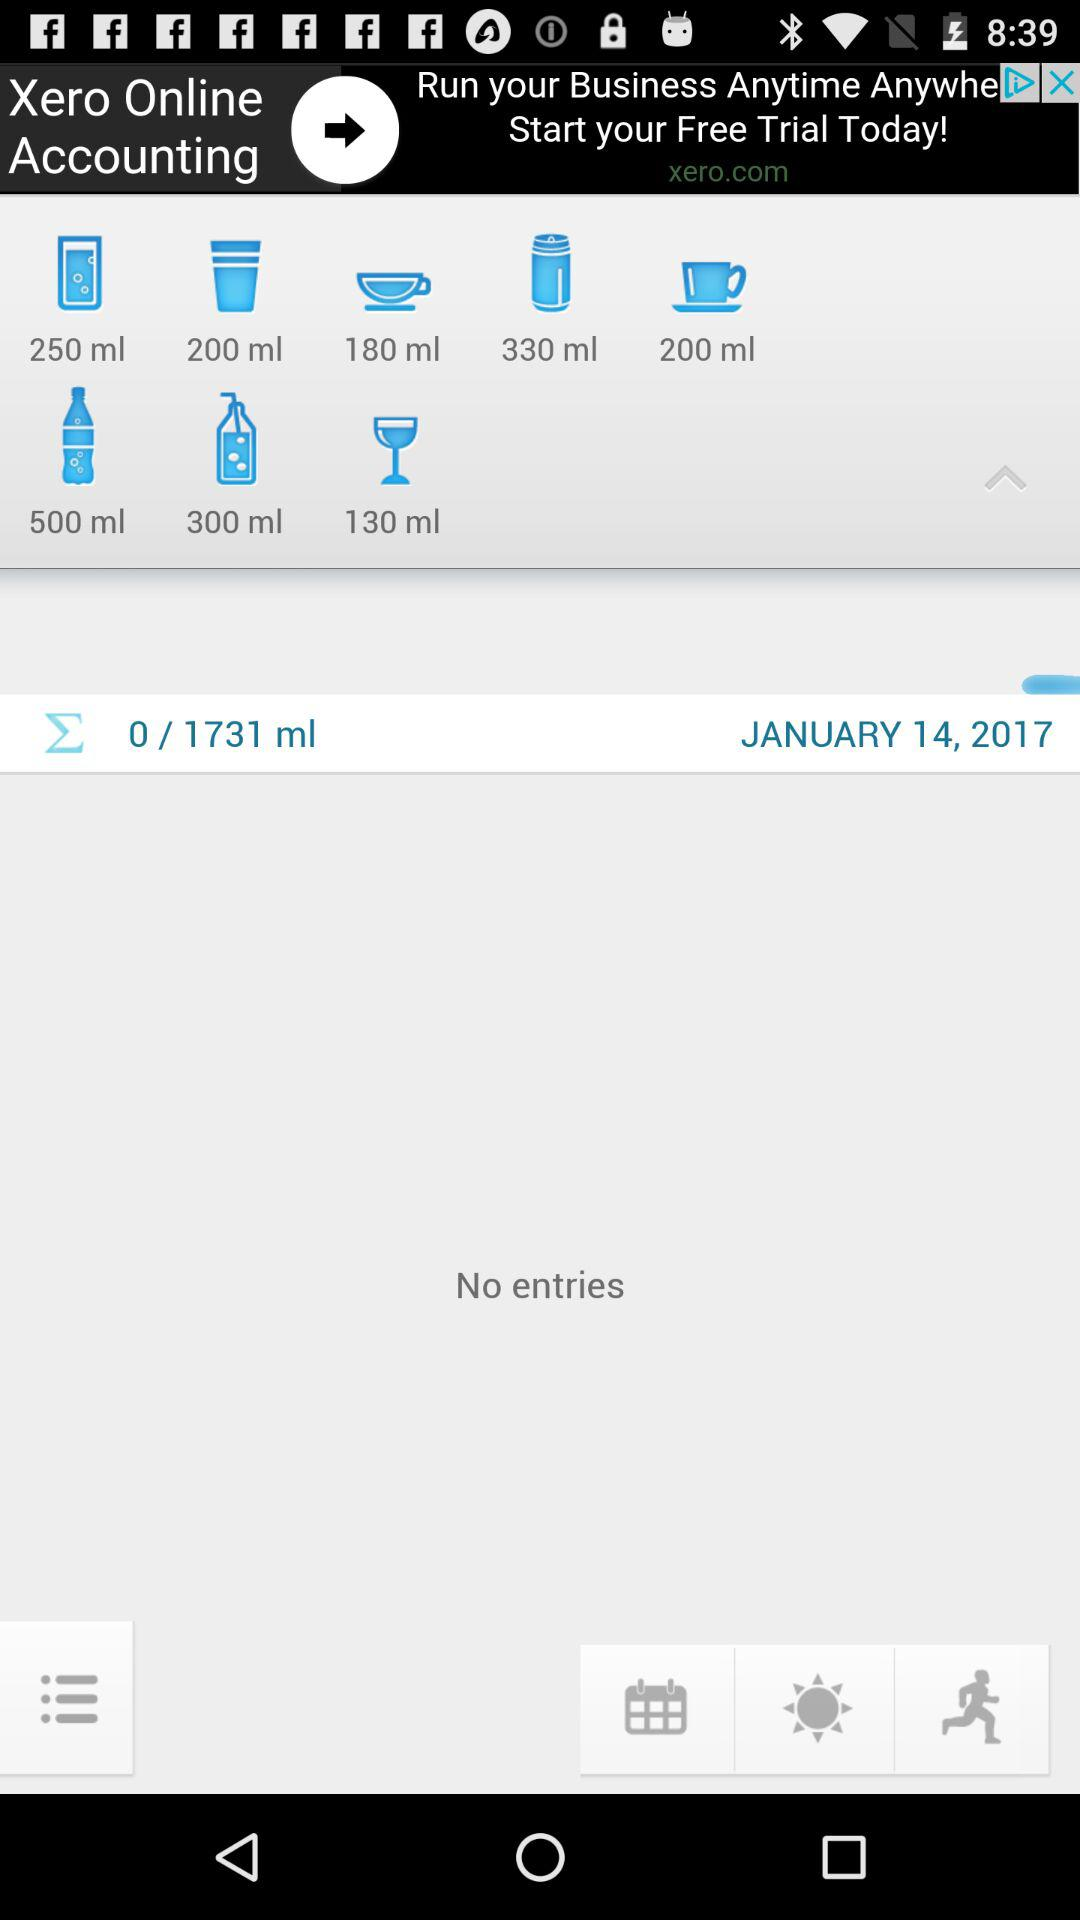What is the total quantity in ml? The total quantity is 1731 ml. 